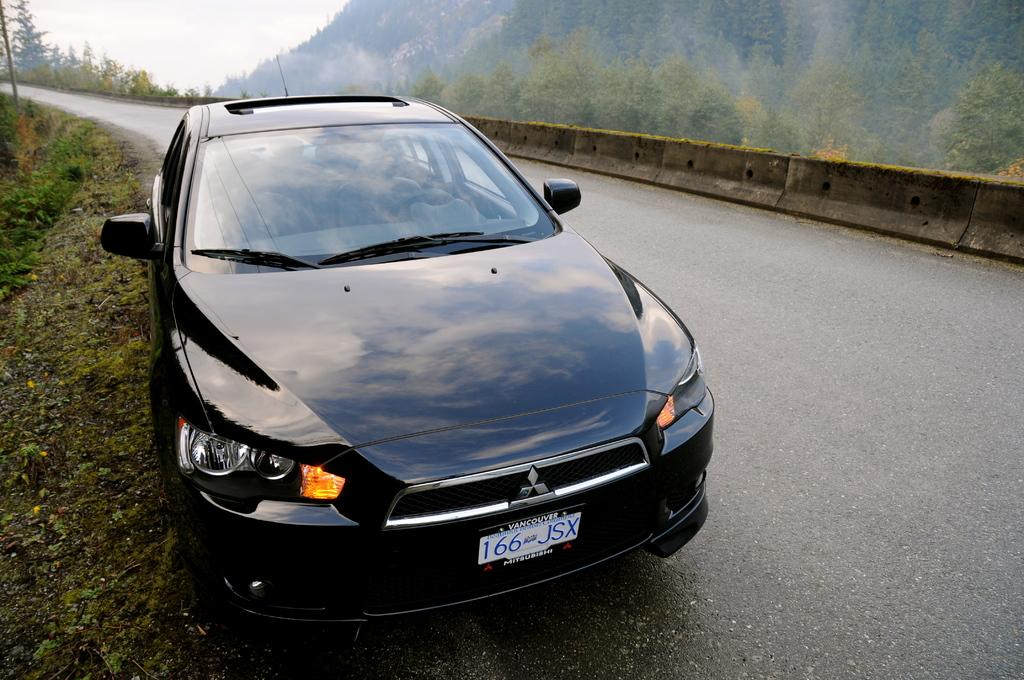What is the main subject of the image? The main subject of the image is a car. Where is the car located in the image? The car is on the road in the image. What can be seen in the background of the image? There are trees and the sky visible in the background of the image. What type of mine can be seen in the image? There is no mine present in the image; it features a car on the road with trees and the sky in the background. 